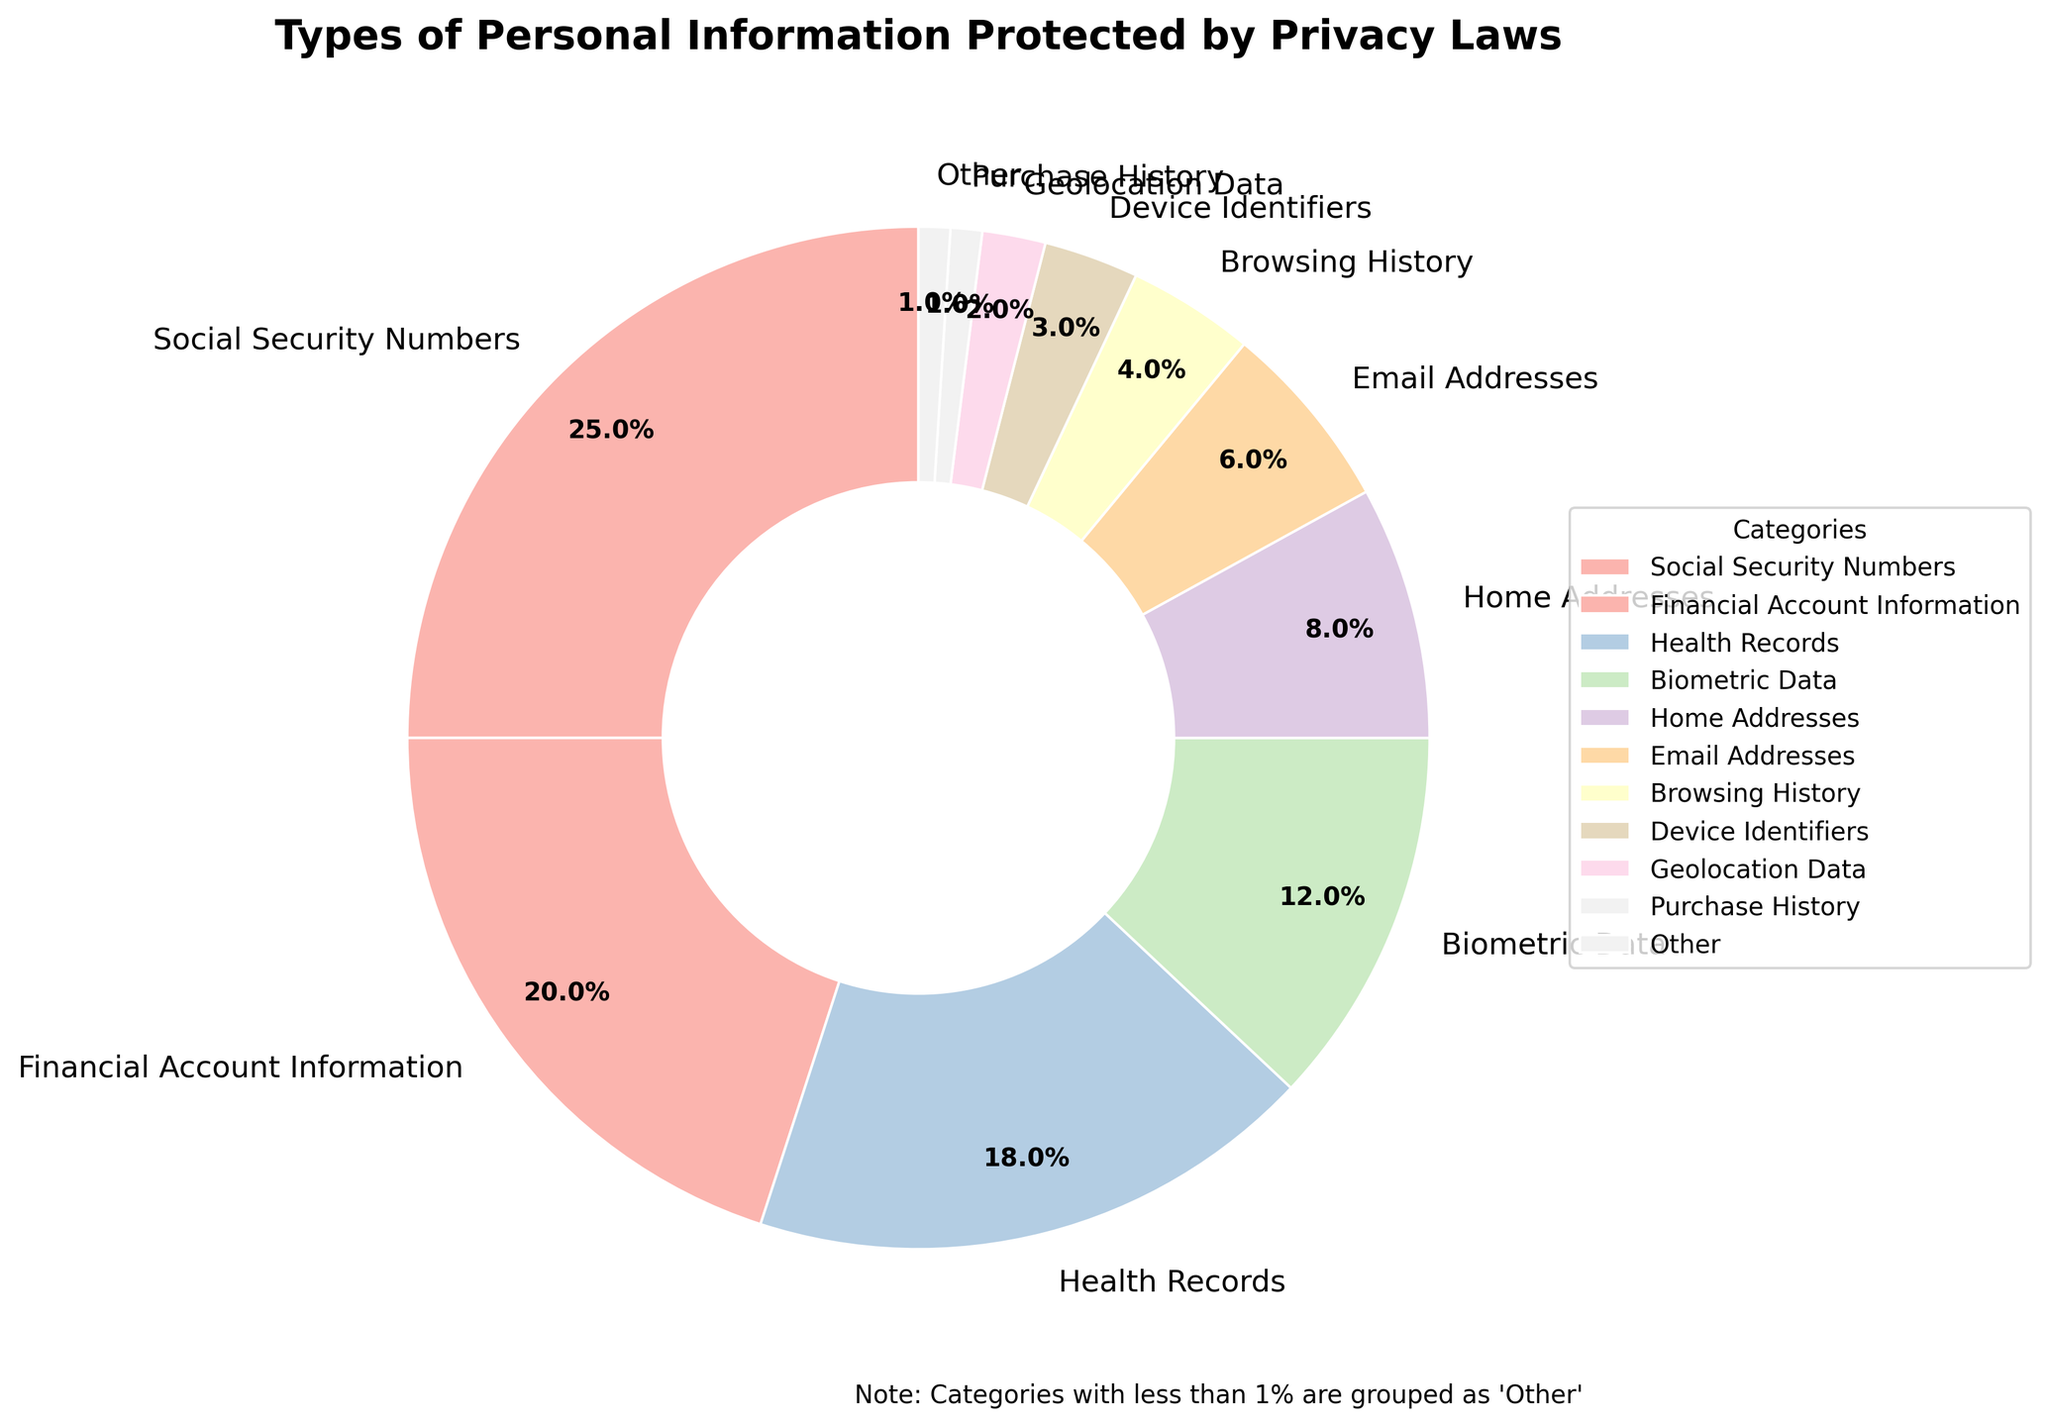what percentage of personal information types falls under the 'Other' category? The 'Other' category includes all the types of personal information with less than 1% share. Summing up the percentages of Purchase History (1%), Political Affiliations (0.5%), Sexual Orientation (0.3%), and Religious Beliefs (0.2%) gives 1.0% + 0.5% + 0.3% + 0.2% = 2%.
Answer: 2% Which category of personal information has the highest percentage? The category with the highest percentage is Social Security Numbers, which is indicated at 25% on the pie chart.
Answer: Social Security Numbers How does the percentage of Financial Account Information compare to Health Records? Financial Account Information holds 20% whereas Health Records hold 18% in the pie chart. Financial Account Information is 2% higher than Health Records.
Answer: 2% higher What is the combined percentage of Email Addresses and Browsing History? The pie chart shows that Email Addresses make up 6% and Browsing History makes up 4%. Adding these percentages gives 6% + 4% = 10%.
Answer: 10% Are there more types of information in the 'Other' category than in the main categories? The 'Other' category comprises 4 types (Purchase History, Political Affiliations, Sexual Orientation, and Religious Beliefs), while the main categories consist of 9 types. Since 9 > 4, there are more main categories than 'Other' categories.
Answer: No Which visual feature distinguishes the 'Other' category in the pie chart? The 'Other' category is represented as a separate segment in the pie chart, often with a distinct color to visually differentiate it from the other categories.
Answer: Separate segment with distinct color How does the percentage of Device Identifiers compare to Geolocation Data? Device Identifiers make up 3% whereas Geolocation Data makes up 2%. Thus, Device Identifiers are 1% higher than Geolocation Data.
Answer: 1% higher What categories, if any, combined make up exactly 50% of the chart? Combining Social Security Numbers (25%) and Financial Account Information (20%) gives 45%, and adding Health Records (18%) takes the total to 63%, which is more than 50%. No combination of categories makes exactly 50%.
Answer: None What is the difference in percentage between the largest and smallest category in the main segments? The largest category is Social Security Numbers at 25%, and the smallest category in the main segments (excluding 'Other') is Geolocation Data at 2%. The difference is 25% - 2% = 23%.
Answer: 23% Which category would increase the 'Other' percentage if included, and by how much? If Geolocation Data (2%) were added to the 'Other' category (2%), the combined percentage for 'Other' would be 2% + 2% = 4%.
Answer: Geolocation Data, 2% 